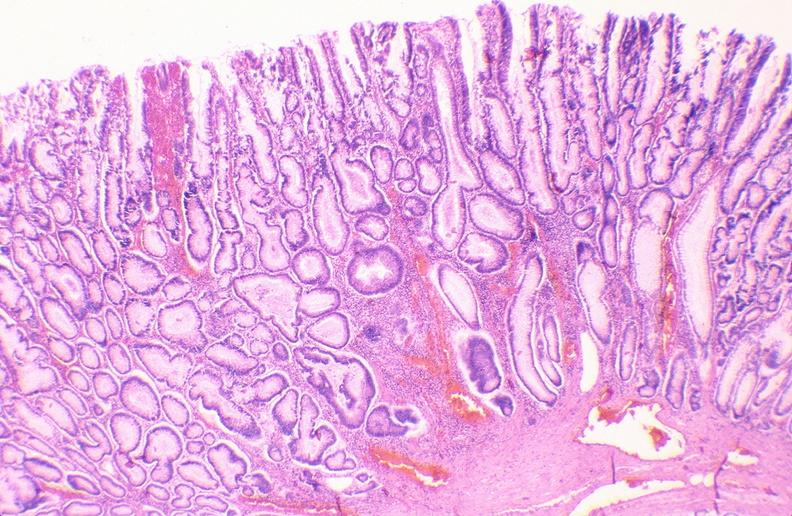does this image show colon, adenomatous polyp?
Answer the question using a single word or phrase. Yes 